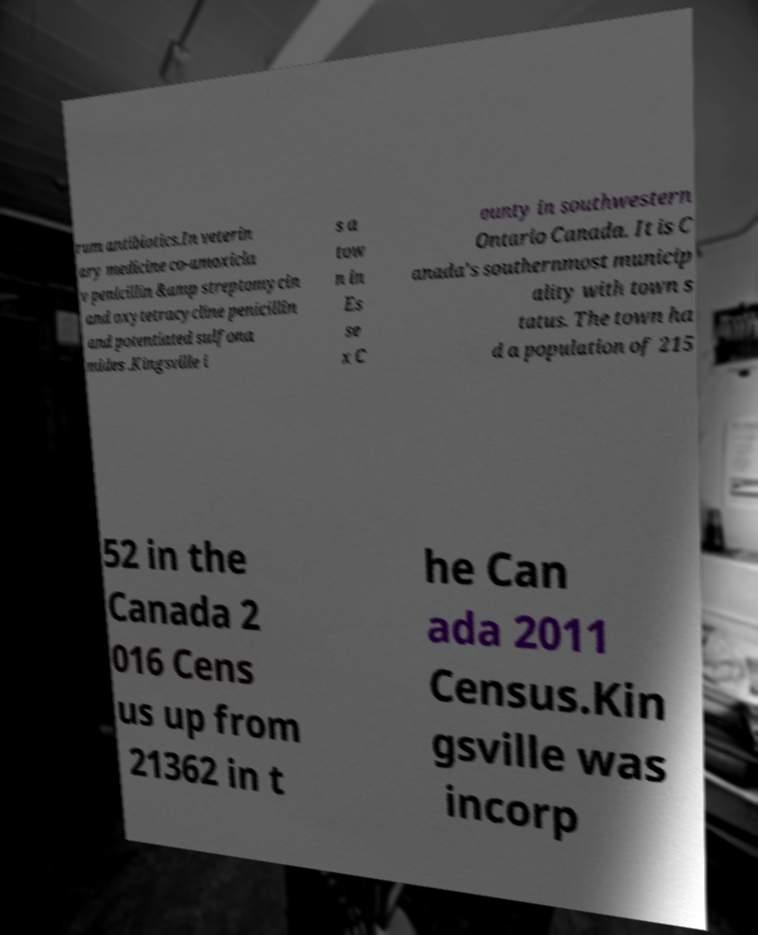For documentation purposes, I need the text within this image transcribed. Could you provide that? rum antibiotics.In veterin ary medicine co-amoxicla v penicillin &amp streptomycin and oxytetracycline penicillin and potentiated sulfona mides .Kingsville i s a tow n in Es se x C ounty in southwestern Ontario Canada. It is C anada's southernmost municip ality with town s tatus. The town ha d a population of 215 52 in the Canada 2 016 Cens us up from 21362 in t he Can ada 2011 Census.Kin gsville was incorp 